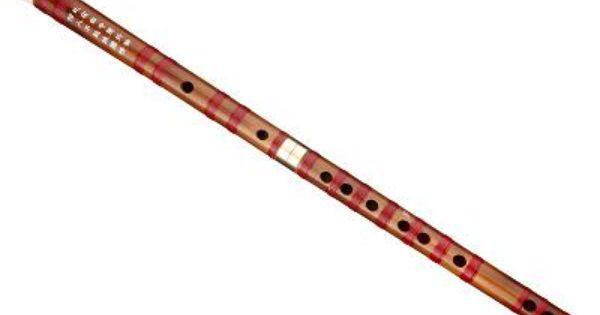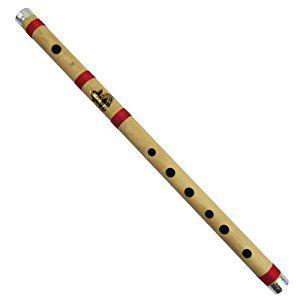The first image is the image on the left, the second image is the image on the right. For the images displayed, is the sentence "The instrument in the image on the right is broken apart into several pieces." factually correct? Answer yes or no. No. The first image is the image on the left, the second image is the image on the right. Given the left and right images, does the statement "One of the instruments is taken apart into two separate pieces." hold true? Answer yes or no. No. 